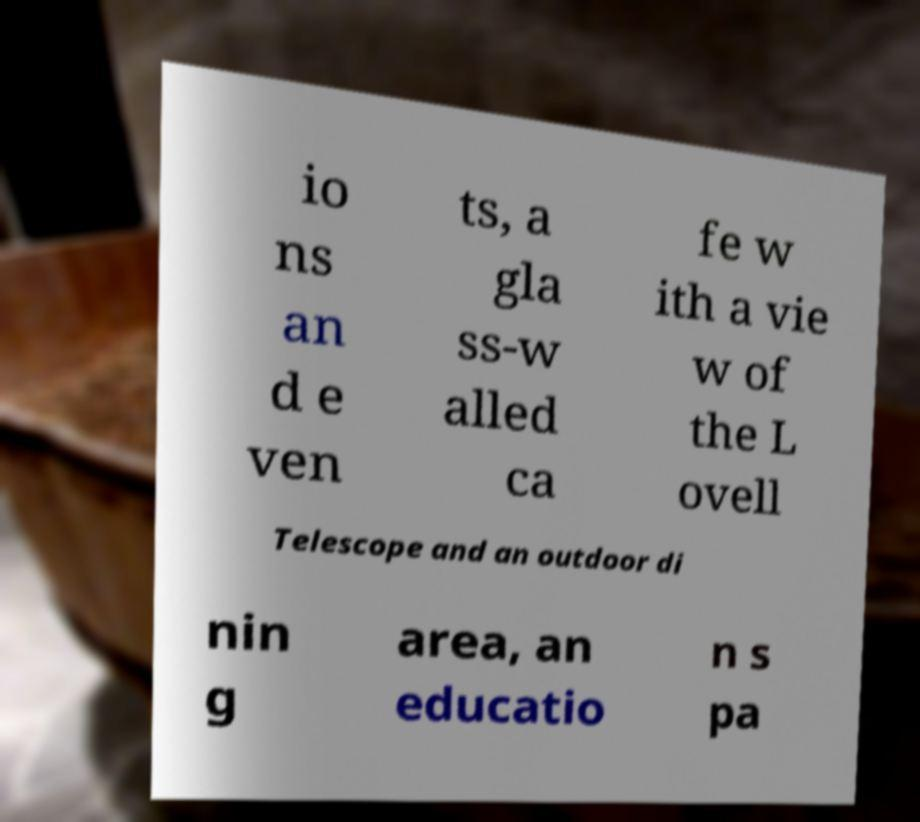I need the written content from this picture converted into text. Can you do that? io ns an d e ven ts, a gla ss-w alled ca fe w ith a vie w of the L ovell Telescope and an outdoor di nin g area, an educatio n s pa 